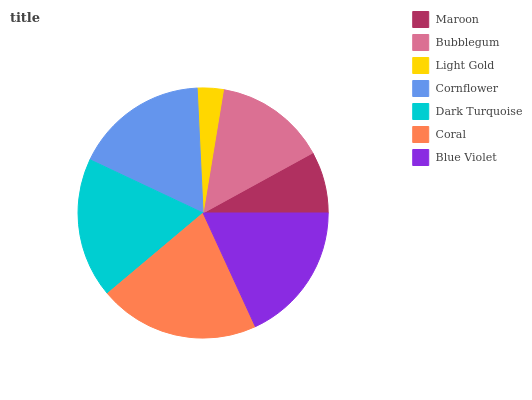Is Light Gold the minimum?
Answer yes or no. Yes. Is Coral the maximum?
Answer yes or no. Yes. Is Bubblegum the minimum?
Answer yes or no. No. Is Bubblegum the maximum?
Answer yes or no. No. Is Bubblegum greater than Maroon?
Answer yes or no. Yes. Is Maroon less than Bubblegum?
Answer yes or no. Yes. Is Maroon greater than Bubblegum?
Answer yes or no. No. Is Bubblegum less than Maroon?
Answer yes or no. No. Is Cornflower the high median?
Answer yes or no. Yes. Is Cornflower the low median?
Answer yes or no. Yes. Is Maroon the high median?
Answer yes or no. No. Is Bubblegum the low median?
Answer yes or no. No. 